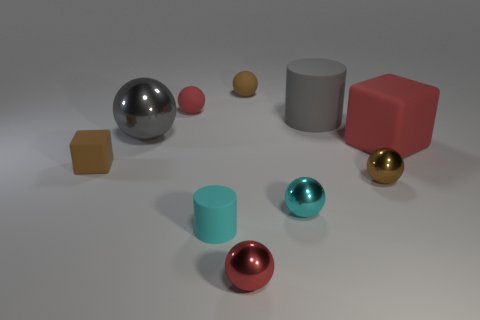Subtract 2 balls. How many balls are left? 4 Subtract all cyan balls. How many balls are left? 5 Subtract all big gray spheres. How many spheres are left? 5 Subtract all yellow balls. Subtract all yellow cubes. How many balls are left? 6 Subtract all balls. How many objects are left? 4 Add 5 tiny rubber balls. How many tiny rubber balls are left? 7 Add 5 metallic blocks. How many metallic blocks exist? 5 Subtract 1 red spheres. How many objects are left? 9 Subtract all big gray metallic balls. Subtract all big gray metal things. How many objects are left? 8 